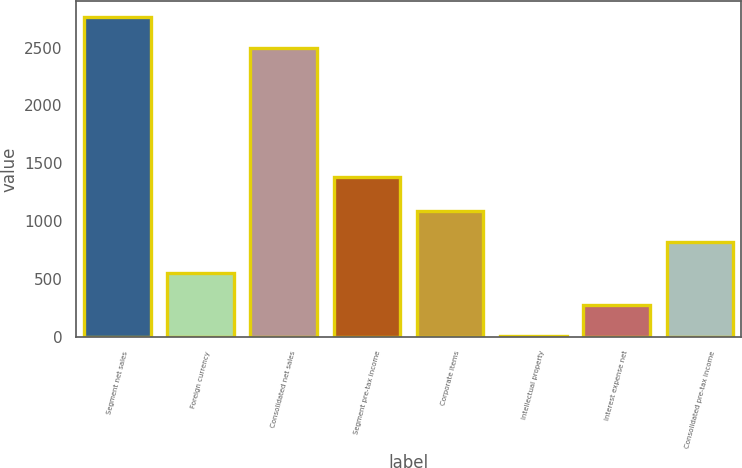Convert chart to OTSL. <chart><loc_0><loc_0><loc_500><loc_500><bar_chart><fcel>Segment net sales<fcel>Foreign currency<fcel>Consolidated net sales<fcel>Segment pre-tax income<fcel>Corporate items<fcel>Intellectual property<fcel>Interest expense net<fcel>Consolidated pre-tax income<nl><fcel>2764.8<fcel>549.2<fcel>2493.7<fcel>1378.5<fcel>1091.4<fcel>7<fcel>278.1<fcel>820.3<nl></chart> 